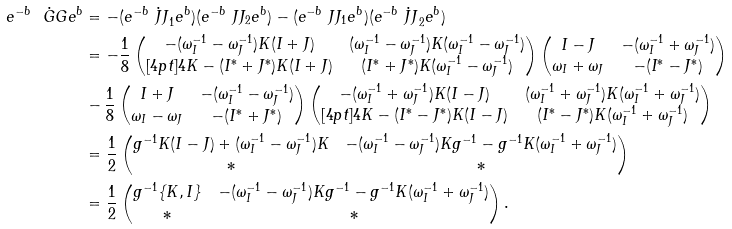<formula> <loc_0><loc_0><loc_500><loc_500>e ^ { - b } \dot { \ G G } e ^ { b } & = - ( e ^ { - b } \dot { \ J J } _ { 1 } e ^ { b } ) ( e ^ { - b } \ J J _ { 2 } e ^ { b } ) - ( e ^ { - b } \ J J _ { 1 } e ^ { b } ) ( e ^ { - b } \dot { \ J J } _ { 2 } e ^ { b } ) \\ & = - \frac { 1 } { 8 } \begin{pmatrix} - ( \omega _ { I } ^ { - 1 } - \omega _ { J } ^ { - 1 } ) K ( I + J ) & ( \omega _ { I } ^ { - 1 } - \omega _ { J } ^ { - 1 } ) K ( \omega _ { I } ^ { - 1 } - \omega _ { J } ^ { - 1 } ) \\ [ 4 p t ] 4 K - ( I ^ { * } + J ^ { * } ) K ( I + J ) & ( I ^ { * } + J ^ { * } ) K ( \omega _ { I } ^ { - 1 } - \omega _ { J } ^ { - 1 } ) \end{pmatrix} \begin{pmatrix} I - J & - ( \omega _ { I } ^ { - 1 } + \omega _ { J } ^ { - 1 } ) \\ \omega _ { I } + \omega _ { J } & - ( I ^ { * } - J ^ { * } ) \end{pmatrix} \\ & - \frac { 1 } { 8 } \begin{pmatrix} I + J & - ( \omega _ { I } ^ { - 1 } - \omega _ { J } ^ { - 1 } ) \\ \omega _ { I } - \omega _ { J } & - ( I ^ { * } + J ^ { * } ) \end{pmatrix} \begin{pmatrix} - ( \omega _ { I } ^ { - 1 } + \omega _ { J } ^ { - 1 } ) K ( I - J ) & ( \omega _ { I } ^ { - 1 } + \omega _ { J } ^ { - 1 } ) K ( \omega _ { I } ^ { - 1 } + \omega _ { J } ^ { - 1 } ) \\ [ 4 p t ] 4 K - ( I ^ { * } - J ^ { * } ) K ( I - J ) & ( I ^ { * } - J ^ { * } ) K ( \omega _ { I } ^ { - 1 } + \omega _ { J } ^ { - 1 } ) \end{pmatrix} \\ & = \frac { 1 } { 2 } \begin{pmatrix} g ^ { - 1 } K ( I - J ) + ( \omega _ { I } ^ { - 1 } - \omega _ { J } ^ { - 1 } ) K & - ( \omega _ { I } ^ { - 1 } - \omega _ { J } ^ { - 1 } ) K g ^ { - 1 } - g ^ { - 1 } K ( \omega _ { I } ^ { - 1 } + \omega _ { J } ^ { - 1 } ) \\ * & * \end{pmatrix} \\ & = \frac { 1 } { 2 } \begin{pmatrix} g ^ { - 1 } \{ K , I \} & - ( \omega _ { I } ^ { - 1 } - \omega _ { J } ^ { - 1 } ) K g ^ { - 1 } - g ^ { - 1 } K ( \omega _ { I } ^ { - 1 } + \omega _ { J } ^ { - 1 } ) \\ * & * \end{pmatrix} .</formula> 